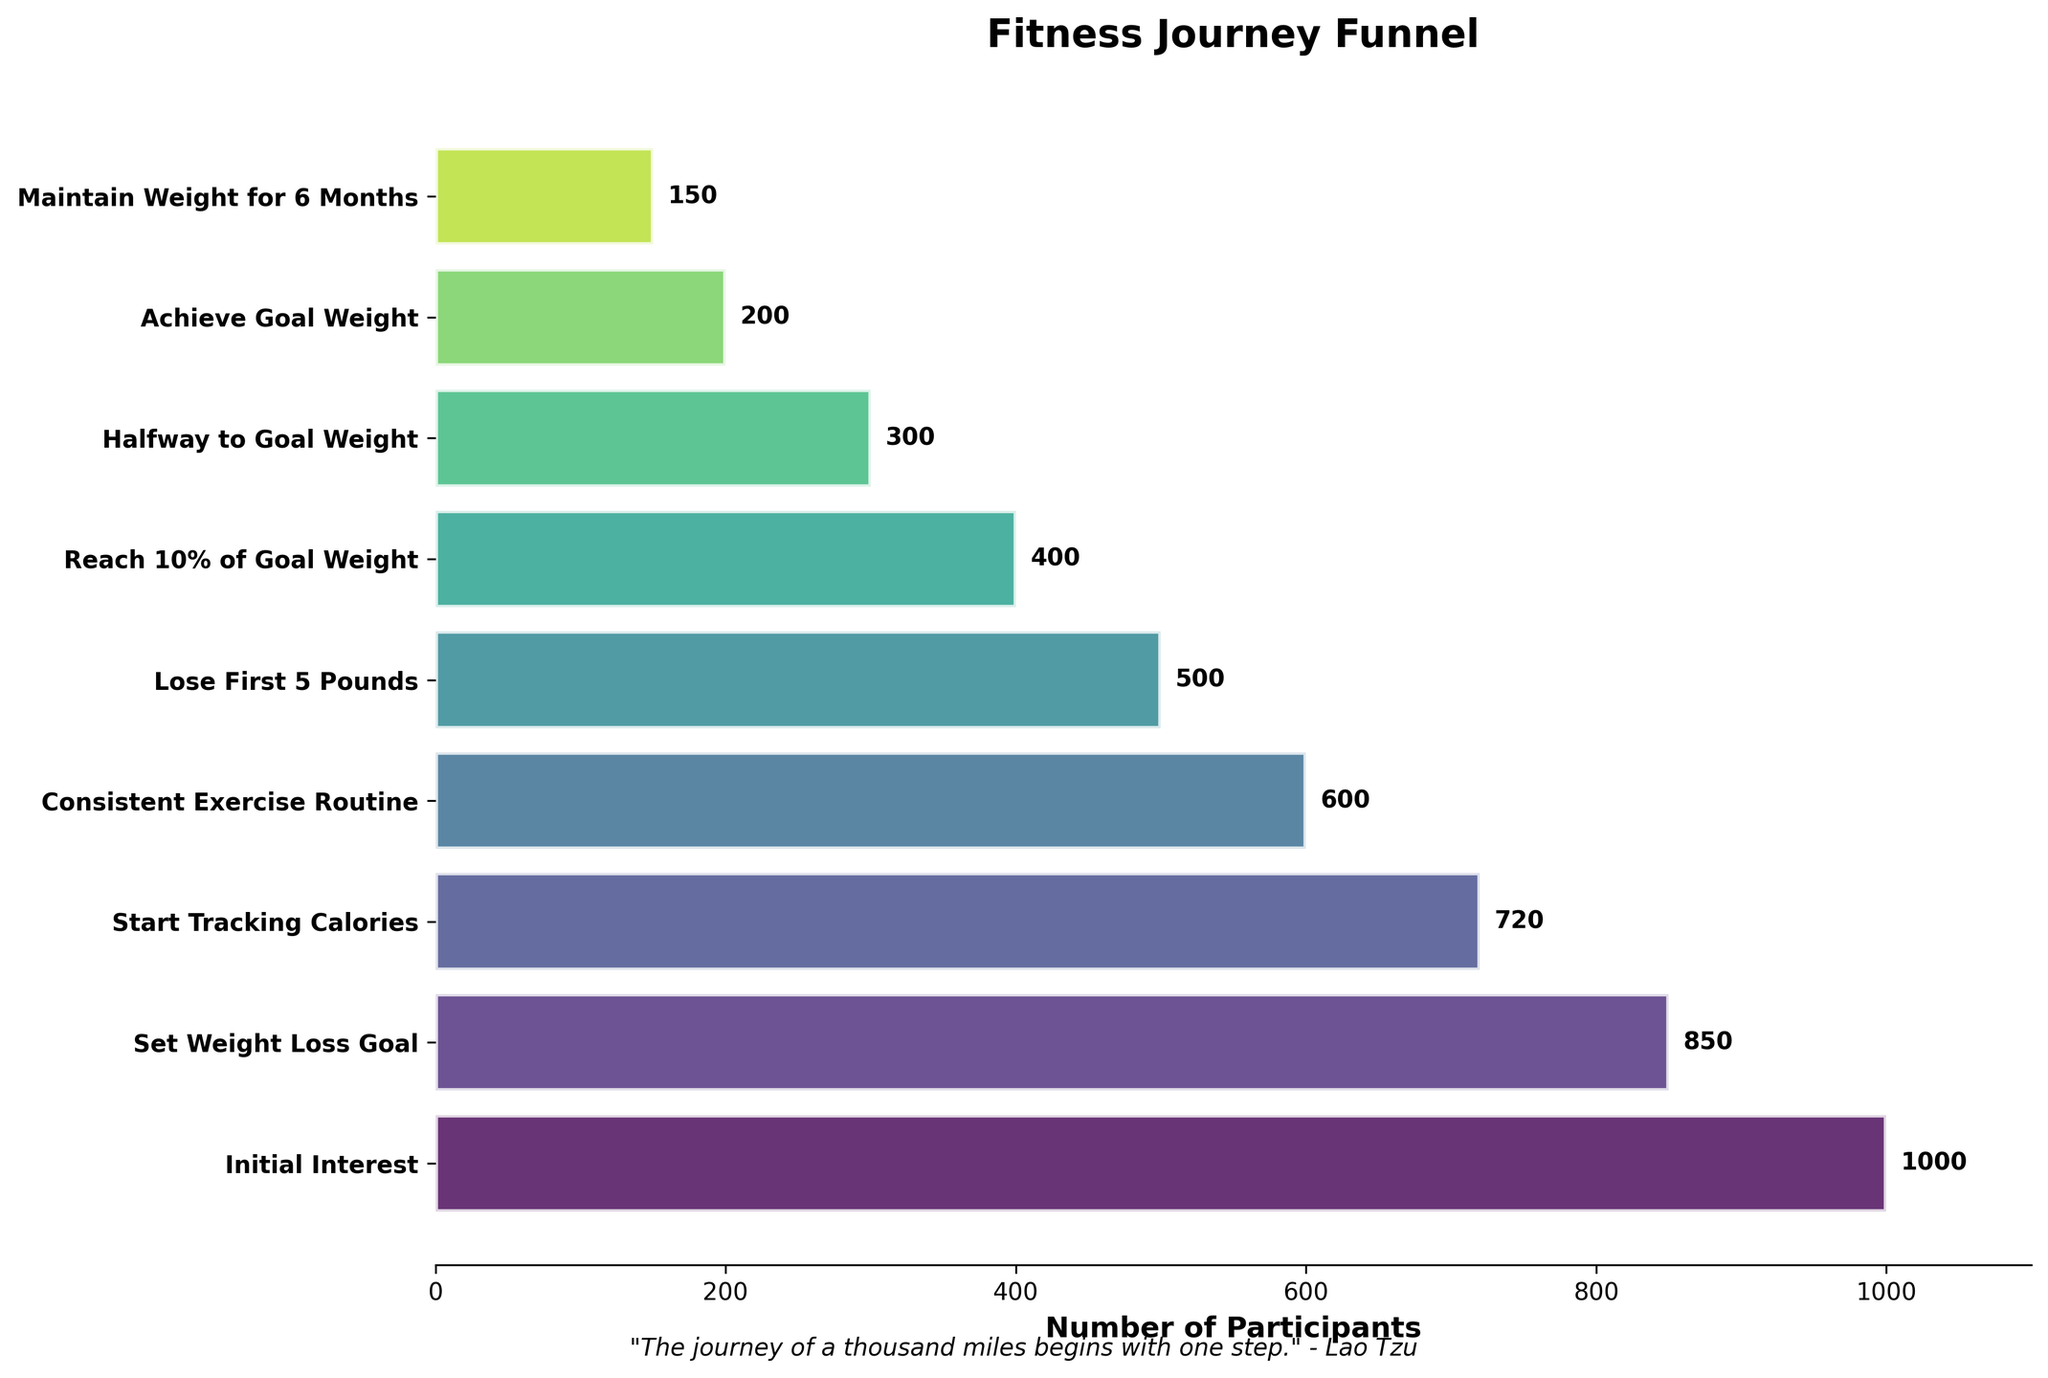How many participants initially showed interest in the fitness journey? The count of participants is given at the beginning of the funnel chart.
Answer: 1000 What's the title of the chart? The title of the chart is located at the top of the figure.
Answer: Fitness Journey Funnel How many participants reached the halfway point to their goal weight? The number of participants for "Halfway to Goal Weight" can be read directly from the chart.
Answer: 300 At which stage did the biggest drop in participant count occur? Compare the differences in participant counts between consecutive stages and identify the maximum drop. The biggest drop is from "Initial Interest" to "Set Weight Loss Goal".
Answer: Initial Interest to Set Weight Loss Goal What percentage of participants who start tracking calories achieve their goal weight? Calculate the percentage by dividing the number of participants who achieved the goal weight (200) by the number who started tracking calories (720) and multiply by 100. (200/720) * 100 = 27.8%
Answer: 27.8% How many stages are there in the fitness journey funnel? Count the number of stages listed on the y-axis.
Answer: 9 Which stage has the smallest number of participants? Identify the stage with the smallest bar (shortest horizontal length). It is "Maintain Weight for 6 Months".
Answer: Maintain Weight for 6 Months What is the difference in participants between those who lost their first 5 pounds and those who reached 10% of their goal weight? Subtract the number of participants who reached 10% of their goal weight (400) from those who lost their first 5 pounds (500). 500 - 400 = 100
Answer: 100 How does the number of participants who achieve their goal weight compare to those who maintain weight for 6 months? Compare the two numbers directly. There are 200 participants who achieved goal weight and 150 who maintained it for 6 months. 200 > 150
Answer: More achieve goal weight than maintain it for 6 months What motivational quote is included at the bottom of the chart? The motivational quote is located at the bottom of the figure.
Answer: "The journey of a thousand miles begins with one step." - Lao Tzu 